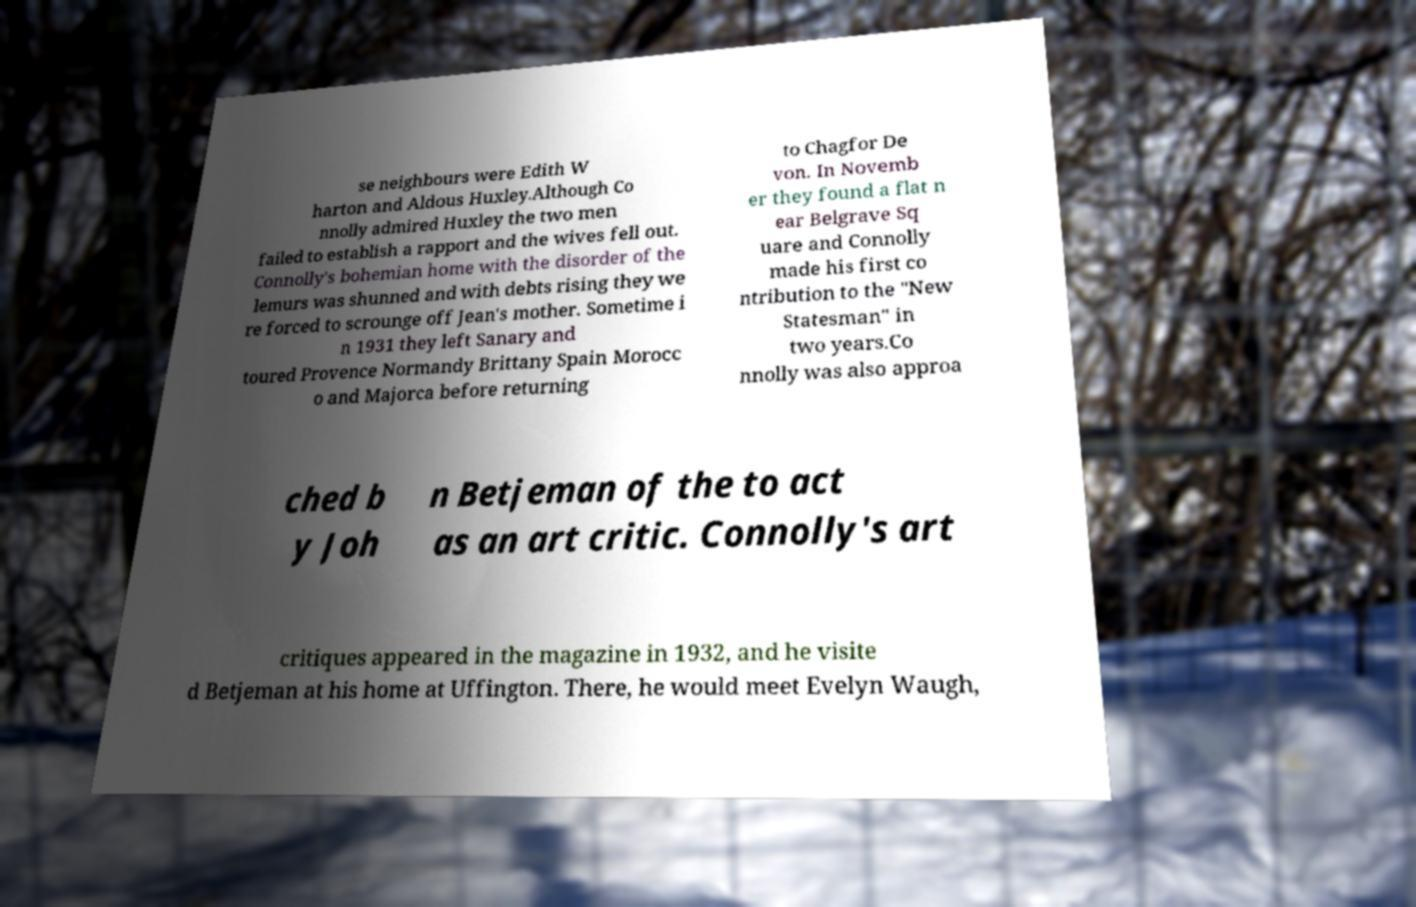For documentation purposes, I need the text within this image transcribed. Could you provide that? se neighbours were Edith W harton and Aldous Huxley.Although Co nnolly admired Huxley the two men failed to establish a rapport and the wives fell out. Connolly's bohemian home with the disorder of the lemurs was shunned and with debts rising they we re forced to scrounge off Jean's mother. Sometime i n 1931 they left Sanary and toured Provence Normandy Brittany Spain Morocc o and Majorca before returning to Chagfor De von. In Novemb er they found a flat n ear Belgrave Sq uare and Connolly made his first co ntribution to the "New Statesman" in two years.Co nnolly was also approa ched b y Joh n Betjeman of the to act as an art critic. Connolly's art critiques appeared in the magazine in 1932, and he visite d Betjeman at his home at Uffington. There, he would meet Evelyn Waugh, 